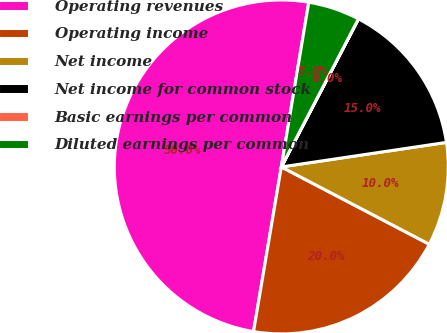Convert chart. <chart><loc_0><loc_0><loc_500><loc_500><pie_chart><fcel>Operating revenues<fcel>Operating income<fcel>Net income<fcel>Net income for common stock<fcel>Basic earnings per common<fcel>Diluted earnings per common<nl><fcel>49.97%<fcel>20.0%<fcel>10.01%<fcel>15.0%<fcel>0.01%<fcel>5.01%<nl></chart> 